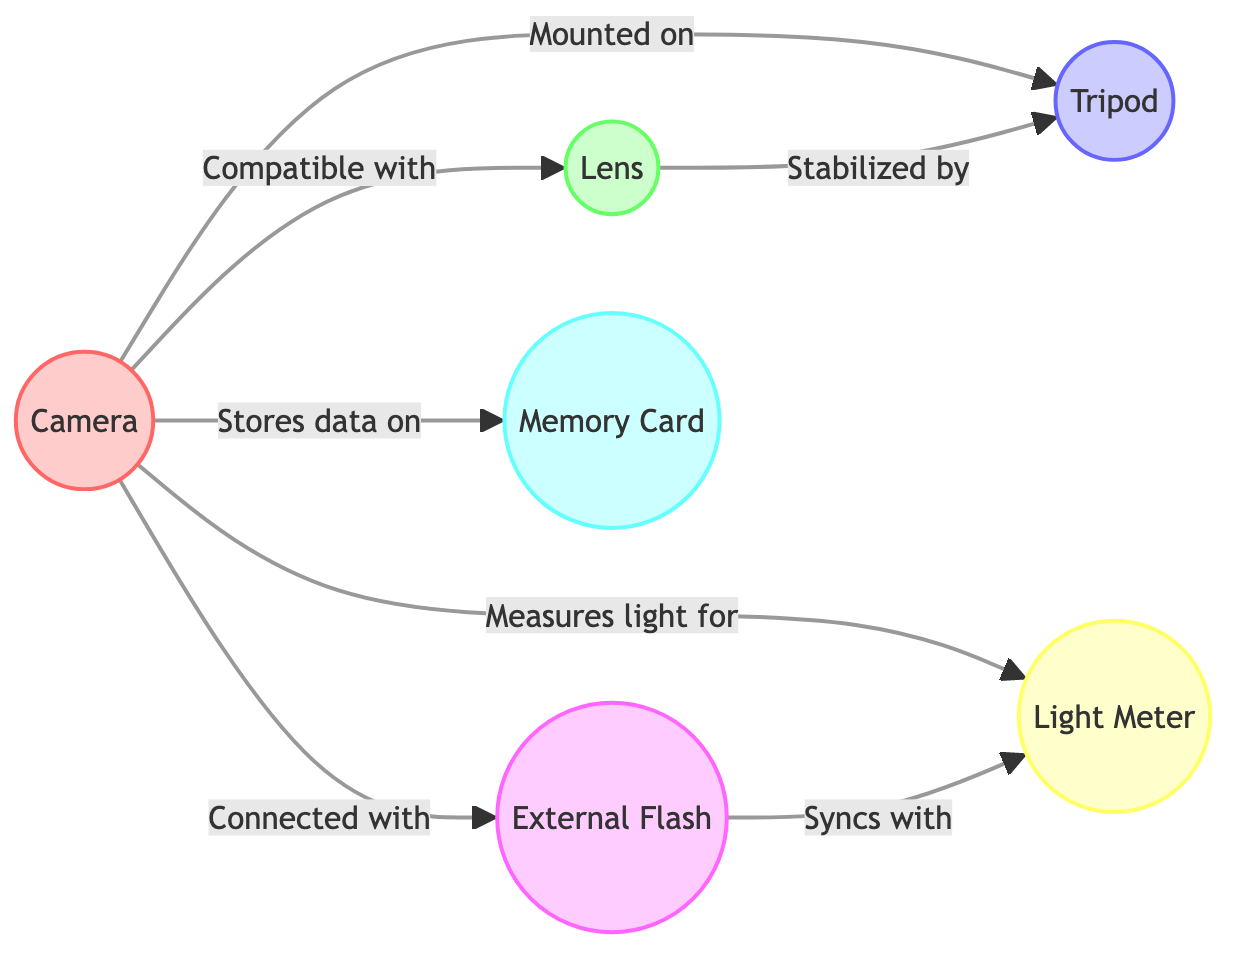What are the different types of cameras represented in the diagram? The nodes in the diagram indicate that there are different types of cameras, specifically "DSLR," "Mirrorless," and "Medium Format" listed under the camera details in the provided data.
Answer: DSLR, Mirrorless, Medium Format How many brands of tripods are listed? The diagram includes a node for Tripod, which details four different brands associated with it: "Manfrotto," "Gitzo," "Benro," and "Joby." Counting these brands yields a total of four.
Answer: 4 What is the relationship between Camera and Light Meter? The diagram shows that the Camera "measures light for" the Light Meter, indicating a direct relationship where the camera interacts with the light meter to assess lighting conditions.
Answer: measures light for Which piece of equipment syncs with the External Flash? The diagram indicates that the Light Meter syncs with the External Flash, establishing a connection where they work together during photography.
Answer: Light Meter What type of memory cards are mentioned in the diagram? The Memory Card node contains types listed as "SD," "CF," "XQD," and "CFexpress," detailing the different formats referenced in the data.
Answer: SD, CF, XQD, CFexpress If a Lens is to be stabilized, which equipment must it be mounted on? The diagram specifies that a Lens is "stabilized by" the Tripod, meaning the tripod serves to stabilize the camera setup that includes the lens.
Answer: Tripod What would a photographer use to measure light conditions for their camera? According to the diagram, the Light Meter is specifically used to measure light for the Camera, making it the right piece of equipment for this task.
Answer: Light Meter How many total connections (links) are depicted in the diagram? The diagram has a total of seven links illustrating the relationships between nodes, which can be counted directly from the links section in the data.
Answer: 7 What type of lens provides a closer view of subjects? The diagram lists "Telephoto" among the types of lenses, and a telephoto lens is specifically designed to capture close-up images of distant subjects, thus serving this purpose.
Answer: Telephoto 